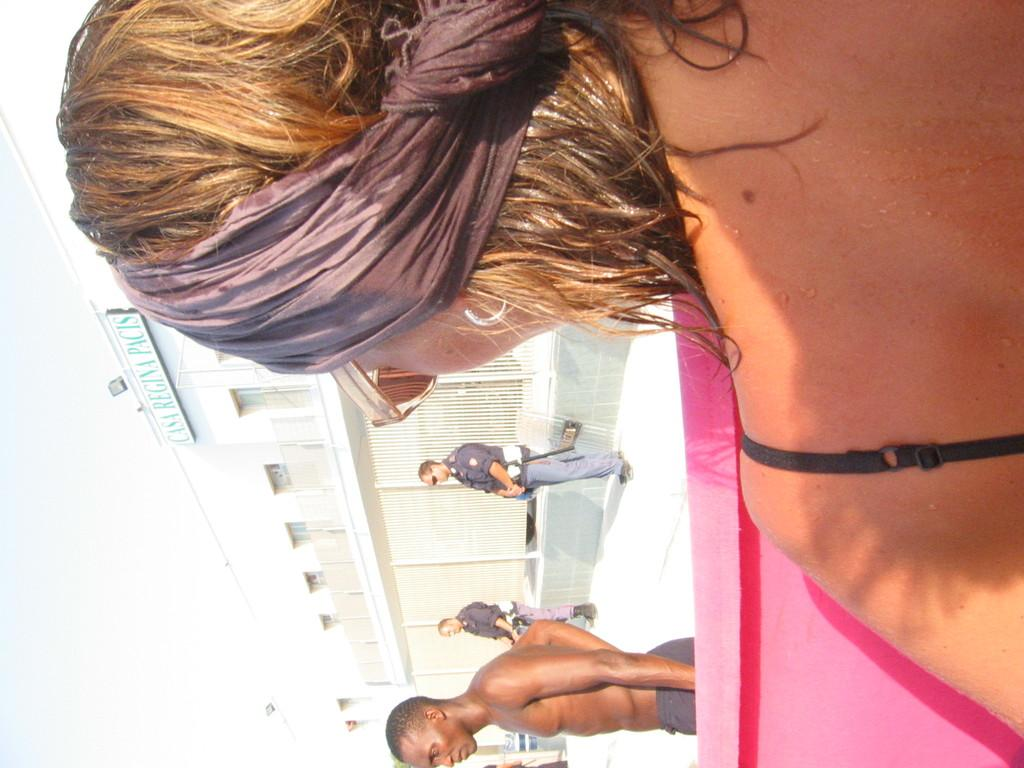What are the persons in the image doing? The persons in the image are on the floor. What can be seen in the background of the image? There is a building and a name board in the background of the image. What is visible above the building and name board? The sky is visible in the background of the image. Reasoning: Let' Let's think step by step in order to produce the conversation. We start by identifying the main subjects in the image, which are the persons on the floor. Then, we expand the conversation to include other elements in the image, such as the building, name board, and sky. Each question is designed to elicit a specific detail about the image that is known from the provided facts. Absurd Question/Answer: What type of current can be seen flowing through the steel in the image? There is no steel or current present in the image. Where is the bedroom located in the image? There is no bedroom present in the image. What type of current can be seen flowing through the steel in the image? There is no steel or current present in the image. Where is the bedroom located in the image? There is no bedroom present in the image. 